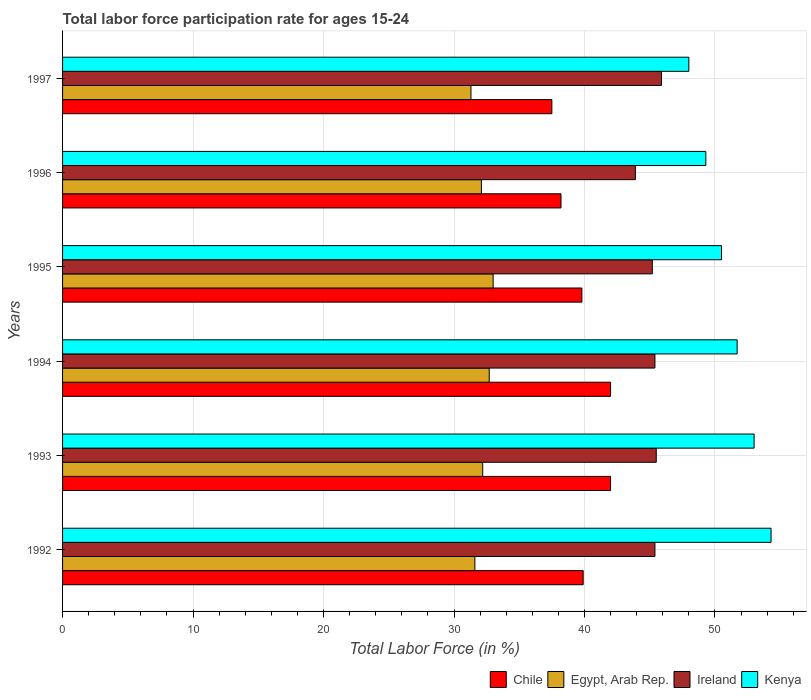How many different coloured bars are there?
Your answer should be very brief. 4. Are the number of bars per tick equal to the number of legend labels?
Give a very brief answer. Yes. What is the label of the 1st group of bars from the top?
Offer a very short reply. 1997. In how many cases, is the number of bars for a given year not equal to the number of legend labels?
Your answer should be compact. 0. What is the labor force participation rate in Ireland in 1992?
Provide a short and direct response. 45.4. Across all years, what is the minimum labor force participation rate in Chile?
Ensure brevity in your answer.  37.5. What is the total labor force participation rate in Chile in the graph?
Ensure brevity in your answer.  239.4. What is the difference between the labor force participation rate in Kenya in 1994 and that in 1995?
Your answer should be compact. 1.2. What is the difference between the labor force participation rate in Egypt, Arab Rep. in 1994 and the labor force participation rate in Kenya in 1995?
Your response must be concise. -17.8. What is the average labor force participation rate in Chile per year?
Your answer should be compact. 39.9. In the year 1995, what is the difference between the labor force participation rate in Ireland and labor force participation rate in Egypt, Arab Rep.?
Ensure brevity in your answer.  12.2. In how many years, is the labor force participation rate in Chile greater than 42 %?
Provide a succinct answer. 0. What is the ratio of the labor force participation rate in Ireland in 1992 to that in 1993?
Keep it short and to the point. 1. What is the difference between the highest and the second highest labor force participation rate in Kenya?
Make the answer very short. 1.3. What is the difference between the highest and the lowest labor force participation rate in Egypt, Arab Rep.?
Keep it short and to the point. 1.7. Is the sum of the labor force participation rate in Chile in 1993 and 1994 greater than the maximum labor force participation rate in Egypt, Arab Rep. across all years?
Make the answer very short. Yes. What does the 1st bar from the top in 1994 represents?
Provide a short and direct response. Kenya. What does the 4th bar from the bottom in 1995 represents?
Ensure brevity in your answer.  Kenya. Is it the case that in every year, the sum of the labor force participation rate in Chile and labor force participation rate in Ireland is greater than the labor force participation rate in Kenya?
Ensure brevity in your answer.  Yes. How many bars are there?
Make the answer very short. 24. How many years are there in the graph?
Your answer should be very brief. 6. Does the graph contain any zero values?
Your answer should be compact. No. Where does the legend appear in the graph?
Ensure brevity in your answer.  Bottom right. How many legend labels are there?
Offer a very short reply. 4. What is the title of the graph?
Give a very brief answer. Total labor force participation rate for ages 15-24. Does "Timor-Leste" appear as one of the legend labels in the graph?
Give a very brief answer. No. What is the label or title of the X-axis?
Offer a very short reply. Total Labor Force (in %). What is the label or title of the Y-axis?
Ensure brevity in your answer.  Years. What is the Total Labor Force (in %) in Chile in 1992?
Your response must be concise. 39.9. What is the Total Labor Force (in %) of Egypt, Arab Rep. in 1992?
Offer a very short reply. 31.6. What is the Total Labor Force (in %) of Ireland in 1992?
Provide a short and direct response. 45.4. What is the Total Labor Force (in %) of Kenya in 1992?
Provide a succinct answer. 54.3. What is the Total Labor Force (in %) of Egypt, Arab Rep. in 1993?
Your answer should be compact. 32.2. What is the Total Labor Force (in %) of Ireland in 1993?
Ensure brevity in your answer.  45.5. What is the Total Labor Force (in %) in Kenya in 1993?
Make the answer very short. 53. What is the Total Labor Force (in %) of Egypt, Arab Rep. in 1994?
Provide a short and direct response. 32.7. What is the Total Labor Force (in %) in Ireland in 1994?
Offer a very short reply. 45.4. What is the Total Labor Force (in %) in Kenya in 1994?
Provide a short and direct response. 51.7. What is the Total Labor Force (in %) of Chile in 1995?
Provide a short and direct response. 39.8. What is the Total Labor Force (in %) of Egypt, Arab Rep. in 1995?
Keep it short and to the point. 33. What is the Total Labor Force (in %) in Ireland in 1995?
Provide a short and direct response. 45.2. What is the Total Labor Force (in %) in Kenya in 1995?
Your answer should be compact. 50.5. What is the Total Labor Force (in %) of Chile in 1996?
Your response must be concise. 38.2. What is the Total Labor Force (in %) in Egypt, Arab Rep. in 1996?
Give a very brief answer. 32.1. What is the Total Labor Force (in %) in Ireland in 1996?
Your answer should be very brief. 43.9. What is the Total Labor Force (in %) in Kenya in 1996?
Keep it short and to the point. 49.3. What is the Total Labor Force (in %) of Chile in 1997?
Ensure brevity in your answer.  37.5. What is the Total Labor Force (in %) in Egypt, Arab Rep. in 1997?
Keep it short and to the point. 31.3. What is the Total Labor Force (in %) in Ireland in 1997?
Provide a short and direct response. 45.9. Across all years, what is the maximum Total Labor Force (in %) in Egypt, Arab Rep.?
Make the answer very short. 33. Across all years, what is the maximum Total Labor Force (in %) of Ireland?
Ensure brevity in your answer.  45.9. Across all years, what is the maximum Total Labor Force (in %) in Kenya?
Your answer should be very brief. 54.3. Across all years, what is the minimum Total Labor Force (in %) of Chile?
Your answer should be very brief. 37.5. Across all years, what is the minimum Total Labor Force (in %) in Egypt, Arab Rep.?
Provide a short and direct response. 31.3. Across all years, what is the minimum Total Labor Force (in %) of Ireland?
Your response must be concise. 43.9. What is the total Total Labor Force (in %) in Chile in the graph?
Offer a very short reply. 239.4. What is the total Total Labor Force (in %) of Egypt, Arab Rep. in the graph?
Your answer should be very brief. 192.9. What is the total Total Labor Force (in %) of Ireland in the graph?
Provide a succinct answer. 271.3. What is the total Total Labor Force (in %) of Kenya in the graph?
Your answer should be very brief. 306.8. What is the difference between the Total Labor Force (in %) of Egypt, Arab Rep. in 1992 and that in 1993?
Your response must be concise. -0.6. What is the difference between the Total Labor Force (in %) in Kenya in 1992 and that in 1993?
Ensure brevity in your answer.  1.3. What is the difference between the Total Labor Force (in %) in Chile in 1992 and that in 1995?
Your answer should be very brief. 0.1. What is the difference between the Total Labor Force (in %) of Ireland in 1992 and that in 1997?
Your answer should be compact. -0.5. What is the difference between the Total Labor Force (in %) in Kenya in 1992 and that in 1997?
Your answer should be very brief. 6.3. What is the difference between the Total Labor Force (in %) in Chile in 1993 and that in 1994?
Your answer should be very brief. 0. What is the difference between the Total Labor Force (in %) in Egypt, Arab Rep. in 1993 and that in 1994?
Ensure brevity in your answer.  -0.5. What is the difference between the Total Labor Force (in %) of Kenya in 1993 and that in 1994?
Offer a very short reply. 1.3. What is the difference between the Total Labor Force (in %) of Egypt, Arab Rep. in 1993 and that in 1995?
Make the answer very short. -0.8. What is the difference between the Total Labor Force (in %) in Chile in 1993 and that in 1996?
Your response must be concise. 3.8. What is the difference between the Total Labor Force (in %) in Egypt, Arab Rep. in 1993 and that in 1996?
Provide a short and direct response. 0.1. What is the difference between the Total Labor Force (in %) in Kenya in 1993 and that in 1996?
Provide a short and direct response. 3.7. What is the difference between the Total Labor Force (in %) in Egypt, Arab Rep. in 1993 and that in 1997?
Provide a short and direct response. 0.9. What is the difference between the Total Labor Force (in %) of Ireland in 1993 and that in 1997?
Give a very brief answer. -0.4. What is the difference between the Total Labor Force (in %) in Egypt, Arab Rep. in 1994 and that in 1995?
Your response must be concise. -0.3. What is the difference between the Total Labor Force (in %) of Ireland in 1994 and that in 1995?
Make the answer very short. 0.2. What is the difference between the Total Labor Force (in %) in Kenya in 1994 and that in 1995?
Ensure brevity in your answer.  1.2. What is the difference between the Total Labor Force (in %) of Ireland in 1994 and that in 1996?
Ensure brevity in your answer.  1.5. What is the difference between the Total Labor Force (in %) of Chile in 1994 and that in 1997?
Your answer should be compact. 4.5. What is the difference between the Total Labor Force (in %) of Egypt, Arab Rep. in 1994 and that in 1997?
Give a very brief answer. 1.4. What is the difference between the Total Labor Force (in %) of Ireland in 1994 and that in 1997?
Provide a succinct answer. -0.5. What is the difference between the Total Labor Force (in %) of Chile in 1995 and that in 1996?
Offer a terse response. 1.6. What is the difference between the Total Labor Force (in %) in Kenya in 1995 and that in 1996?
Offer a terse response. 1.2. What is the difference between the Total Labor Force (in %) of Ireland in 1995 and that in 1997?
Make the answer very short. -0.7. What is the difference between the Total Labor Force (in %) in Kenya in 1995 and that in 1997?
Provide a succinct answer. 2.5. What is the difference between the Total Labor Force (in %) of Chile in 1996 and that in 1997?
Your response must be concise. 0.7. What is the difference between the Total Labor Force (in %) of Ireland in 1996 and that in 1997?
Your answer should be compact. -2. What is the difference between the Total Labor Force (in %) in Kenya in 1996 and that in 1997?
Give a very brief answer. 1.3. What is the difference between the Total Labor Force (in %) in Chile in 1992 and the Total Labor Force (in %) in Egypt, Arab Rep. in 1993?
Offer a terse response. 7.7. What is the difference between the Total Labor Force (in %) in Egypt, Arab Rep. in 1992 and the Total Labor Force (in %) in Kenya in 1993?
Ensure brevity in your answer.  -21.4. What is the difference between the Total Labor Force (in %) in Ireland in 1992 and the Total Labor Force (in %) in Kenya in 1993?
Offer a terse response. -7.6. What is the difference between the Total Labor Force (in %) of Chile in 1992 and the Total Labor Force (in %) of Ireland in 1994?
Your answer should be compact. -5.5. What is the difference between the Total Labor Force (in %) in Egypt, Arab Rep. in 1992 and the Total Labor Force (in %) in Kenya in 1994?
Your answer should be very brief. -20.1. What is the difference between the Total Labor Force (in %) of Ireland in 1992 and the Total Labor Force (in %) of Kenya in 1994?
Provide a short and direct response. -6.3. What is the difference between the Total Labor Force (in %) of Chile in 1992 and the Total Labor Force (in %) of Egypt, Arab Rep. in 1995?
Keep it short and to the point. 6.9. What is the difference between the Total Labor Force (in %) of Chile in 1992 and the Total Labor Force (in %) of Ireland in 1995?
Offer a very short reply. -5.3. What is the difference between the Total Labor Force (in %) in Chile in 1992 and the Total Labor Force (in %) in Kenya in 1995?
Make the answer very short. -10.6. What is the difference between the Total Labor Force (in %) of Egypt, Arab Rep. in 1992 and the Total Labor Force (in %) of Kenya in 1995?
Offer a very short reply. -18.9. What is the difference between the Total Labor Force (in %) of Ireland in 1992 and the Total Labor Force (in %) of Kenya in 1995?
Make the answer very short. -5.1. What is the difference between the Total Labor Force (in %) in Chile in 1992 and the Total Labor Force (in %) in Ireland in 1996?
Make the answer very short. -4. What is the difference between the Total Labor Force (in %) in Chile in 1992 and the Total Labor Force (in %) in Kenya in 1996?
Give a very brief answer. -9.4. What is the difference between the Total Labor Force (in %) in Egypt, Arab Rep. in 1992 and the Total Labor Force (in %) in Kenya in 1996?
Ensure brevity in your answer.  -17.7. What is the difference between the Total Labor Force (in %) of Ireland in 1992 and the Total Labor Force (in %) of Kenya in 1996?
Keep it short and to the point. -3.9. What is the difference between the Total Labor Force (in %) of Chile in 1992 and the Total Labor Force (in %) of Kenya in 1997?
Offer a very short reply. -8.1. What is the difference between the Total Labor Force (in %) in Egypt, Arab Rep. in 1992 and the Total Labor Force (in %) in Ireland in 1997?
Provide a short and direct response. -14.3. What is the difference between the Total Labor Force (in %) in Egypt, Arab Rep. in 1992 and the Total Labor Force (in %) in Kenya in 1997?
Offer a terse response. -16.4. What is the difference between the Total Labor Force (in %) of Chile in 1993 and the Total Labor Force (in %) of Egypt, Arab Rep. in 1994?
Your answer should be compact. 9.3. What is the difference between the Total Labor Force (in %) of Chile in 1993 and the Total Labor Force (in %) of Ireland in 1994?
Offer a terse response. -3.4. What is the difference between the Total Labor Force (in %) in Chile in 1993 and the Total Labor Force (in %) in Kenya in 1994?
Provide a succinct answer. -9.7. What is the difference between the Total Labor Force (in %) of Egypt, Arab Rep. in 1993 and the Total Labor Force (in %) of Ireland in 1994?
Provide a short and direct response. -13.2. What is the difference between the Total Labor Force (in %) in Egypt, Arab Rep. in 1993 and the Total Labor Force (in %) in Kenya in 1994?
Make the answer very short. -19.5. What is the difference between the Total Labor Force (in %) of Ireland in 1993 and the Total Labor Force (in %) of Kenya in 1994?
Ensure brevity in your answer.  -6.2. What is the difference between the Total Labor Force (in %) in Chile in 1993 and the Total Labor Force (in %) in Ireland in 1995?
Your answer should be compact. -3.2. What is the difference between the Total Labor Force (in %) of Egypt, Arab Rep. in 1993 and the Total Labor Force (in %) of Ireland in 1995?
Ensure brevity in your answer.  -13. What is the difference between the Total Labor Force (in %) of Egypt, Arab Rep. in 1993 and the Total Labor Force (in %) of Kenya in 1995?
Your response must be concise. -18.3. What is the difference between the Total Labor Force (in %) of Chile in 1993 and the Total Labor Force (in %) of Kenya in 1996?
Offer a very short reply. -7.3. What is the difference between the Total Labor Force (in %) of Egypt, Arab Rep. in 1993 and the Total Labor Force (in %) of Ireland in 1996?
Offer a very short reply. -11.7. What is the difference between the Total Labor Force (in %) in Egypt, Arab Rep. in 1993 and the Total Labor Force (in %) in Kenya in 1996?
Your response must be concise. -17.1. What is the difference between the Total Labor Force (in %) of Chile in 1993 and the Total Labor Force (in %) of Ireland in 1997?
Give a very brief answer. -3.9. What is the difference between the Total Labor Force (in %) of Egypt, Arab Rep. in 1993 and the Total Labor Force (in %) of Ireland in 1997?
Offer a very short reply. -13.7. What is the difference between the Total Labor Force (in %) in Egypt, Arab Rep. in 1993 and the Total Labor Force (in %) in Kenya in 1997?
Provide a short and direct response. -15.8. What is the difference between the Total Labor Force (in %) in Ireland in 1993 and the Total Labor Force (in %) in Kenya in 1997?
Make the answer very short. -2.5. What is the difference between the Total Labor Force (in %) of Chile in 1994 and the Total Labor Force (in %) of Egypt, Arab Rep. in 1995?
Offer a very short reply. 9. What is the difference between the Total Labor Force (in %) in Chile in 1994 and the Total Labor Force (in %) in Kenya in 1995?
Provide a short and direct response. -8.5. What is the difference between the Total Labor Force (in %) in Egypt, Arab Rep. in 1994 and the Total Labor Force (in %) in Ireland in 1995?
Keep it short and to the point. -12.5. What is the difference between the Total Labor Force (in %) in Egypt, Arab Rep. in 1994 and the Total Labor Force (in %) in Kenya in 1995?
Keep it short and to the point. -17.8. What is the difference between the Total Labor Force (in %) of Chile in 1994 and the Total Labor Force (in %) of Ireland in 1996?
Provide a short and direct response. -1.9. What is the difference between the Total Labor Force (in %) in Chile in 1994 and the Total Labor Force (in %) in Kenya in 1996?
Ensure brevity in your answer.  -7.3. What is the difference between the Total Labor Force (in %) of Egypt, Arab Rep. in 1994 and the Total Labor Force (in %) of Kenya in 1996?
Provide a succinct answer. -16.6. What is the difference between the Total Labor Force (in %) in Ireland in 1994 and the Total Labor Force (in %) in Kenya in 1996?
Provide a succinct answer. -3.9. What is the difference between the Total Labor Force (in %) of Chile in 1994 and the Total Labor Force (in %) of Kenya in 1997?
Provide a succinct answer. -6. What is the difference between the Total Labor Force (in %) in Egypt, Arab Rep. in 1994 and the Total Labor Force (in %) in Ireland in 1997?
Keep it short and to the point. -13.2. What is the difference between the Total Labor Force (in %) of Egypt, Arab Rep. in 1994 and the Total Labor Force (in %) of Kenya in 1997?
Your answer should be compact. -15.3. What is the difference between the Total Labor Force (in %) in Ireland in 1994 and the Total Labor Force (in %) in Kenya in 1997?
Your answer should be compact. -2.6. What is the difference between the Total Labor Force (in %) of Chile in 1995 and the Total Labor Force (in %) of Ireland in 1996?
Your response must be concise. -4.1. What is the difference between the Total Labor Force (in %) of Chile in 1995 and the Total Labor Force (in %) of Kenya in 1996?
Offer a terse response. -9.5. What is the difference between the Total Labor Force (in %) of Egypt, Arab Rep. in 1995 and the Total Labor Force (in %) of Kenya in 1996?
Offer a terse response. -16.3. What is the difference between the Total Labor Force (in %) in Chile in 1995 and the Total Labor Force (in %) in Egypt, Arab Rep. in 1997?
Make the answer very short. 8.5. What is the difference between the Total Labor Force (in %) in Chile in 1996 and the Total Labor Force (in %) in Egypt, Arab Rep. in 1997?
Offer a very short reply. 6.9. What is the difference between the Total Labor Force (in %) in Chile in 1996 and the Total Labor Force (in %) in Ireland in 1997?
Provide a succinct answer. -7.7. What is the difference between the Total Labor Force (in %) of Egypt, Arab Rep. in 1996 and the Total Labor Force (in %) of Kenya in 1997?
Offer a terse response. -15.9. What is the average Total Labor Force (in %) in Chile per year?
Your response must be concise. 39.9. What is the average Total Labor Force (in %) in Egypt, Arab Rep. per year?
Make the answer very short. 32.15. What is the average Total Labor Force (in %) in Ireland per year?
Provide a succinct answer. 45.22. What is the average Total Labor Force (in %) in Kenya per year?
Offer a very short reply. 51.13. In the year 1992, what is the difference between the Total Labor Force (in %) in Chile and Total Labor Force (in %) in Kenya?
Make the answer very short. -14.4. In the year 1992, what is the difference between the Total Labor Force (in %) of Egypt, Arab Rep. and Total Labor Force (in %) of Ireland?
Ensure brevity in your answer.  -13.8. In the year 1992, what is the difference between the Total Labor Force (in %) in Egypt, Arab Rep. and Total Labor Force (in %) in Kenya?
Provide a short and direct response. -22.7. In the year 1992, what is the difference between the Total Labor Force (in %) of Ireland and Total Labor Force (in %) of Kenya?
Your answer should be very brief. -8.9. In the year 1993, what is the difference between the Total Labor Force (in %) of Chile and Total Labor Force (in %) of Ireland?
Make the answer very short. -3.5. In the year 1993, what is the difference between the Total Labor Force (in %) in Chile and Total Labor Force (in %) in Kenya?
Your answer should be compact. -11. In the year 1993, what is the difference between the Total Labor Force (in %) of Egypt, Arab Rep. and Total Labor Force (in %) of Kenya?
Make the answer very short. -20.8. In the year 1994, what is the difference between the Total Labor Force (in %) of Chile and Total Labor Force (in %) of Ireland?
Ensure brevity in your answer.  -3.4. In the year 1994, what is the difference between the Total Labor Force (in %) in Chile and Total Labor Force (in %) in Kenya?
Offer a terse response. -9.7. In the year 1994, what is the difference between the Total Labor Force (in %) in Ireland and Total Labor Force (in %) in Kenya?
Provide a short and direct response. -6.3. In the year 1995, what is the difference between the Total Labor Force (in %) of Chile and Total Labor Force (in %) of Egypt, Arab Rep.?
Ensure brevity in your answer.  6.8. In the year 1995, what is the difference between the Total Labor Force (in %) in Egypt, Arab Rep. and Total Labor Force (in %) in Kenya?
Your response must be concise. -17.5. In the year 1995, what is the difference between the Total Labor Force (in %) in Ireland and Total Labor Force (in %) in Kenya?
Keep it short and to the point. -5.3. In the year 1996, what is the difference between the Total Labor Force (in %) of Chile and Total Labor Force (in %) of Egypt, Arab Rep.?
Offer a very short reply. 6.1. In the year 1996, what is the difference between the Total Labor Force (in %) of Chile and Total Labor Force (in %) of Kenya?
Your answer should be compact. -11.1. In the year 1996, what is the difference between the Total Labor Force (in %) in Egypt, Arab Rep. and Total Labor Force (in %) in Ireland?
Ensure brevity in your answer.  -11.8. In the year 1996, what is the difference between the Total Labor Force (in %) in Egypt, Arab Rep. and Total Labor Force (in %) in Kenya?
Provide a succinct answer. -17.2. In the year 1996, what is the difference between the Total Labor Force (in %) of Ireland and Total Labor Force (in %) of Kenya?
Your answer should be very brief. -5.4. In the year 1997, what is the difference between the Total Labor Force (in %) of Egypt, Arab Rep. and Total Labor Force (in %) of Ireland?
Your answer should be very brief. -14.6. In the year 1997, what is the difference between the Total Labor Force (in %) of Egypt, Arab Rep. and Total Labor Force (in %) of Kenya?
Keep it short and to the point. -16.7. In the year 1997, what is the difference between the Total Labor Force (in %) of Ireland and Total Labor Force (in %) of Kenya?
Offer a terse response. -2.1. What is the ratio of the Total Labor Force (in %) in Chile in 1992 to that in 1993?
Your answer should be compact. 0.95. What is the ratio of the Total Labor Force (in %) in Egypt, Arab Rep. in 1992 to that in 1993?
Offer a very short reply. 0.98. What is the ratio of the Total Labor Force (in %) in Kenya in 1992 to that in 1993?
Make the answer very short. 1.02. What is the ratio of the Total Labor Force (in %) in Chile in 1992 to that in 1994?
Your response must be concise. 0.95. What is the ratio of the Total Labor Force (in %) of Egypt, Arab Rep. in 1992 to that in 1994?
Provide a short and direct response. 0.97. What is the ratio of the Total Labor Force (in %) of Kenya in 1992 to that in 1994?
Provide a succinct answer. 1.05. What is the ratio of the Total Labor Force (in %) in Chile in 1992 to that in 1995?
Your response must be concise. 1. What is the ratio of the Total Labor Force (in %) in Egypt, Arab Rep. in 1992 to that in 1995?
Ensure brevity in your answer.  0.96. What is the ratio of the Total Labor Force (in %) in Kenya in 1992 to that in 1995?
Your answer should be compact. 1.08. What is the ratio of the Total Labor Force (in %) of Chile in 1992 to that in 1996?
Provide a short and direct response. 1.04. What is the ratio of the Total Labor Force (in %) in Egypt, Arab Rep. in 1992 to that in 1996?
Make the answer very short. 0.98. What is the ratio of the Total Labor Force (in %) of Ireland in 1992 to that in 1996?
Provide a short and direct response. 1.03. What is the ratio of the Total Labor Force (in %) of Kenya in 1992 to that in 1996?
Offer a very short reply. 1.1. What is the ratio of the Total Labor Force (in %) of Chile in 1992 to that in 1997?
Your answer should be compact. 1.06. What is the ratio of the Total Labor Force (in %) of Egypt, Arab Rep. in 1992 to that in 1997?
Your answer should be very brief. 1.01. What is the ratio of the Total Labor Force (in %) of Ireland in 1992 to that in 1997?
Make the answer very short. 0.99. What is the ratio of the Total Labor Force (in %) in Kenya in 1992 to that in 1997?
Ensure brevity in your answer.  1.13. What is the ratio of the Total Labor Force (in %) in Chile in 1993 to that in 1994?
Your response must be concise. 1. What is the ratio of the Total Labor Force (in %) of Egypt, Arab Rep. in 1993 to that in 1994?
Provide a short and direct response. 0.98. What is the ratio of the Total Labor Force (in %) of Kenya in 1993 to that in 1994?
Make the answer very short. 1.03. What is the ratio of the Total Labor Force (in %) of Chile in 1993 to that in 1995?
Offer a terse response. 1.06. What is the ratio of the Total Labor Force (in %) of Egypt, Arab Rep. in 1993 to that in 1995?
Provide a succinct answer. 0.98. What is the ratio of the Total Labor Force (in %) in Ireland in 1993 to that in 1995?
Your answer should be compact. 1.01. What is the ratio of the Total Labor Force (in %) of Kenya in 1993 to that in 1995?
Make the answer very short. 1.05. What is the ratio of the Total Labor Force (in %) in Chile in 1993 to that in 1996?
Ensure brevity in your answer.  1.1. What is the ratio of the Total Labor Force (in %) of Ireland in 1993 to that in 1996?
Offer a terse response. 1.04. What is the ratio of the Total Labor Force (in %) of Kenya in 1993 to that in 1996?
Keep it short and to the point. 1.08. What is the ratio of the Total Labor Force (in %) of Chile in 1993 to that in 1997?
Your answer should be very brief. 1.12. What is the ratio of the Total Labor Force (in %) in Egypt, Arab Rep. in 1993 to that in 1997?
Offer a very short reply. 1.03. What is the ratio of the Total Labor Force (in %) of Kenya in 1993 to that in 1997?
Your answer should be compact. 1.1. What is the ratio of the Total Labor Force (in %) in Chile in 1994 to that in 1995?
Your response must be concise. 1.06. What is the ratio of the Total Labor Force (in %) of Egypt, Arab Rep. in 1994 to that in 1995?
Your response must be concise. 0.99. What is the ratio of the Total Labor Force (in %) in Kenya in 1994 to that in 1995?
Your answer should be compact. 1.02. What is the ratio of the Total Labor Force (in %) of Chile in 1994 to that in 1996?
Your response must be concise. 1.1. What is the ratio of the Total Labor Force (in %) of Egypt, Arab Rep. in 1994 to that in 1996?
Provide a succinct answer. 1.02. What is the ratio of the Total Labor Force (in %) in Ireland in 1994 to that in 1996?
Offer a terse response. 1.03. What is the ratio of the Total Labor Force (in %) in Kenya in 1994 to that in 1996?
Make the answer very short. 1.05. What is the ratio of the Total Labor Force (in %) in Chile in 1994 to that in 1997?
Make the answer very short. 1.12. What is the ratio of the Total Labor Force (in %) of Egypt, Arab Rep. in 1994 to that in 1997?
Your answer should be very brief. 1.04. What is the ratio of the Total Labor Force (in %) in Ireland in 1994 to that in 1997?
Give a very brief answer. 0.99. What is the ratio of the Total Labor Force (in %) of Kenya in 1994 to that in 1997?
Make the answer very short. 1.08. What is the ratio of the Total Labor Force (in %) in Chile in 1995 to that in 1996?
Offer a terse response. 1.04. What is the ratio of the Total Labor Force (in %) of Egypt, Arab Rep. in 1995 to that in 1996?
Make the answer very short. 1.03. What is the ratio of the Total Labor Force (in %) of Ireland in 1995 to that in 1996?
Provide a succinct answer. 1.03. What is the ratio of the Total Labor Force (in %) in Kenya in 1995 to that in 1996?
Offer a terse response. 1.02. What is the ratio of the Total Labor Force (in %) of Chile in 1995 to that in 1997?
Offer a very short reply. 1.06. What is the ratio of the Total Labor Force (in %) of Egypt, Arab Rep. in 1995 to that in 1997?
Make the answer very short. 1.05. What is the ratio of the Total Labor Force (in %) in Ireland in 1995 to that in 1997?
Offer a very short reply. 0.98. What is the ratio of the Total Labor Force (in %) in Kenya in 1995 to that in 1997?
Give a very brief answer. 1.05. What is the ratio of the Total Labor Force (in %) of Chile in 1996 to that in 1997?
Provide a succinct answer. 1.02. What is the ratio of the Total Labor Force (in %) in Egypt, Arab Rep. in 1996 to that in 1997?
Provide a succinct answer. 1.03. What is the ratio of the Total Labor Force (in %) of Ireland in 1996 to that in 1997?
Your response must be concise. 0.96. What is the ratio of the Total Labor Force (in %) of Kenya in 1996 to that in 1997?
Your answer should be very brief. 1.03. What is the difference between the highest and the second highest Total Labor Force (in %) of Egypt, Arab Rep.?
Keep it short and to the point. 0.3. What is the difference between the highest and the second highest Total Labor Force (in %) in Kenya?
Provide a short and direct response. 1.3. What is the difference between the highest and the lowest Total Labor Force (in %) of Chile?
Your answer should be very brief. 4.5. What is the difference between the highest and the lowest Total Labor Force (in %) of Egypt, Arab Rep.?
Make the answer very short. 1.7. What is the difference between the highest and the lowest Total Labor Force (in %) of Kenya?
Keep it short and to the point. 6.3. 